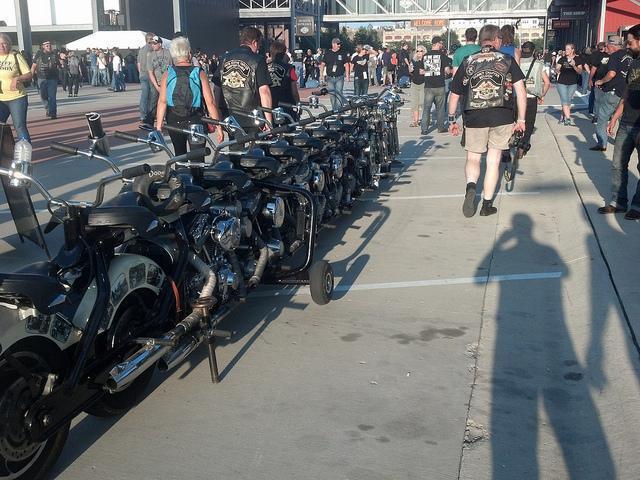What event will the people participate in?
Choose the correct response and explain in the format: 'Answer: answer
Rationale: rationale.'
Options: Motorcycle parade, marathon, protest, touring. Answer: motorcycle parade.
Rationale: There are tons of motorcycles in the street. 